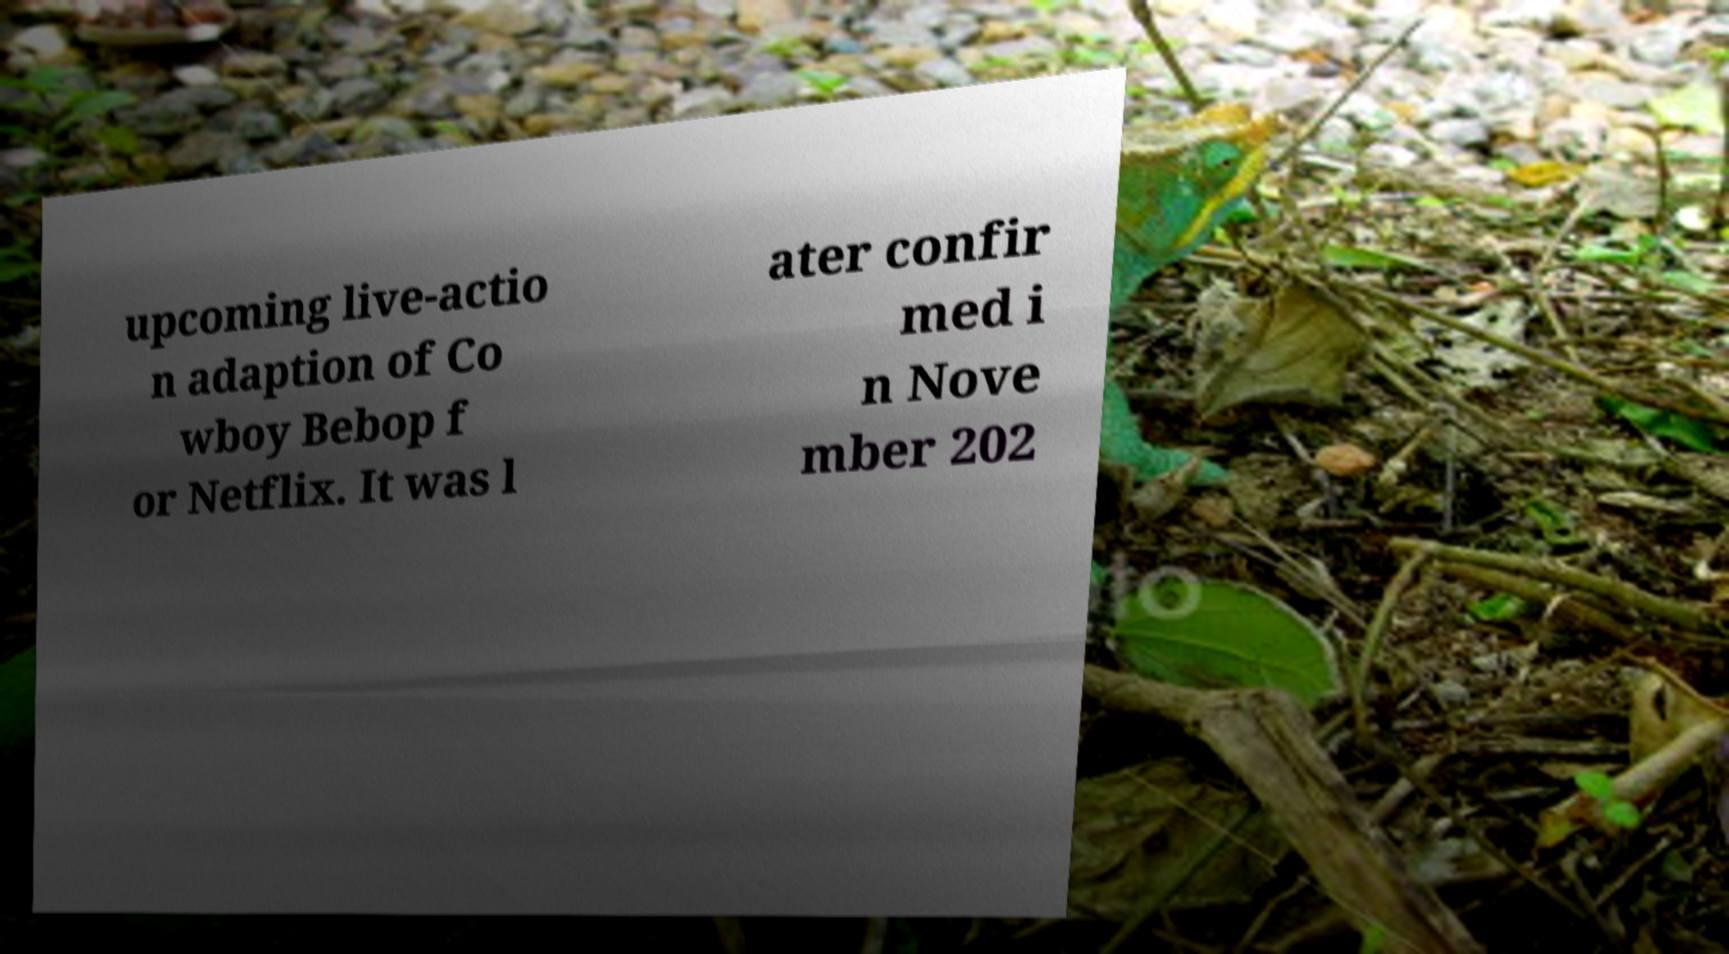Could you assist in decoding the text presented in this image and type it out clearly? upcoming live-actio n adaption of Co wboy Bebop f or Netflix. It was l ater confir med i n Nove mber 202 